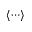<formula> <loc_0><loc_0><loc_500><loc_500>\langle { \cdots } \rangle</formula> 